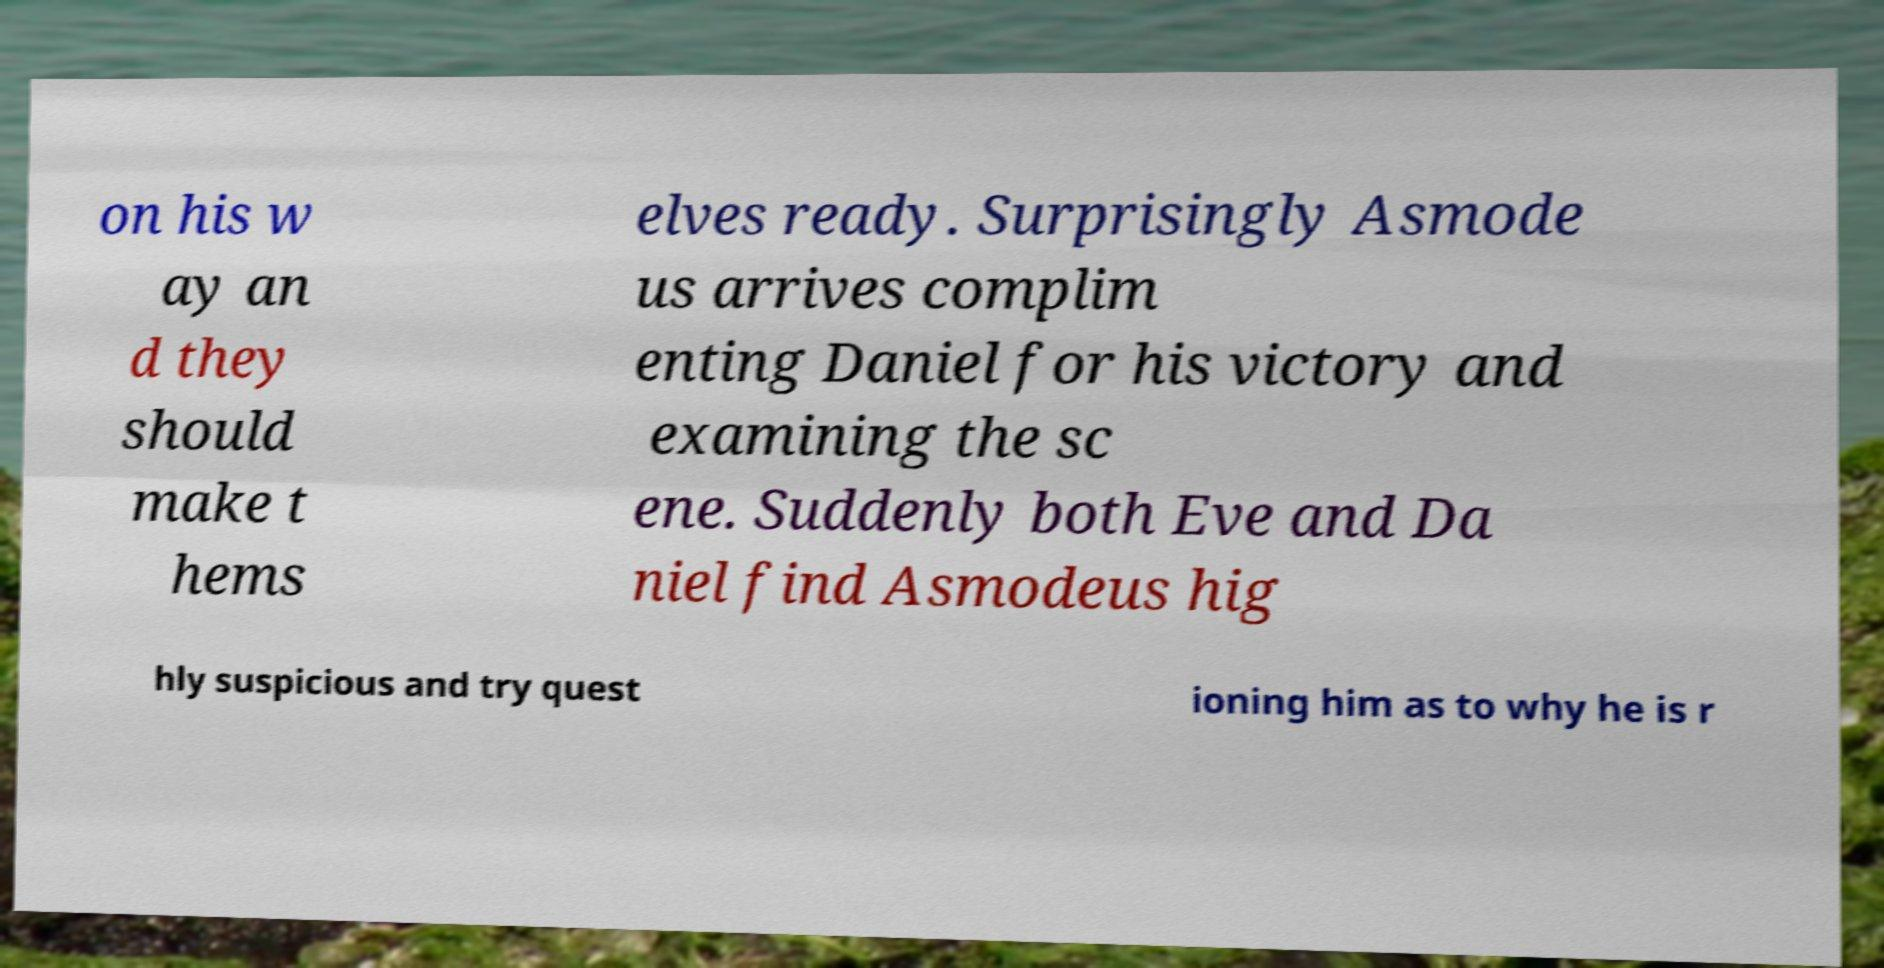What messages or text are displayed in this image? I need them in a readable, typed format. on his w ay an d they should make t hems elves ready. Surprisingly Asmode us arrives complim enting Daniel for his victory and examining the sc ene. Suddenly both Eve and Da niel find Asmodeus hig hly suspicious and try quest ioning him as to why he is r 